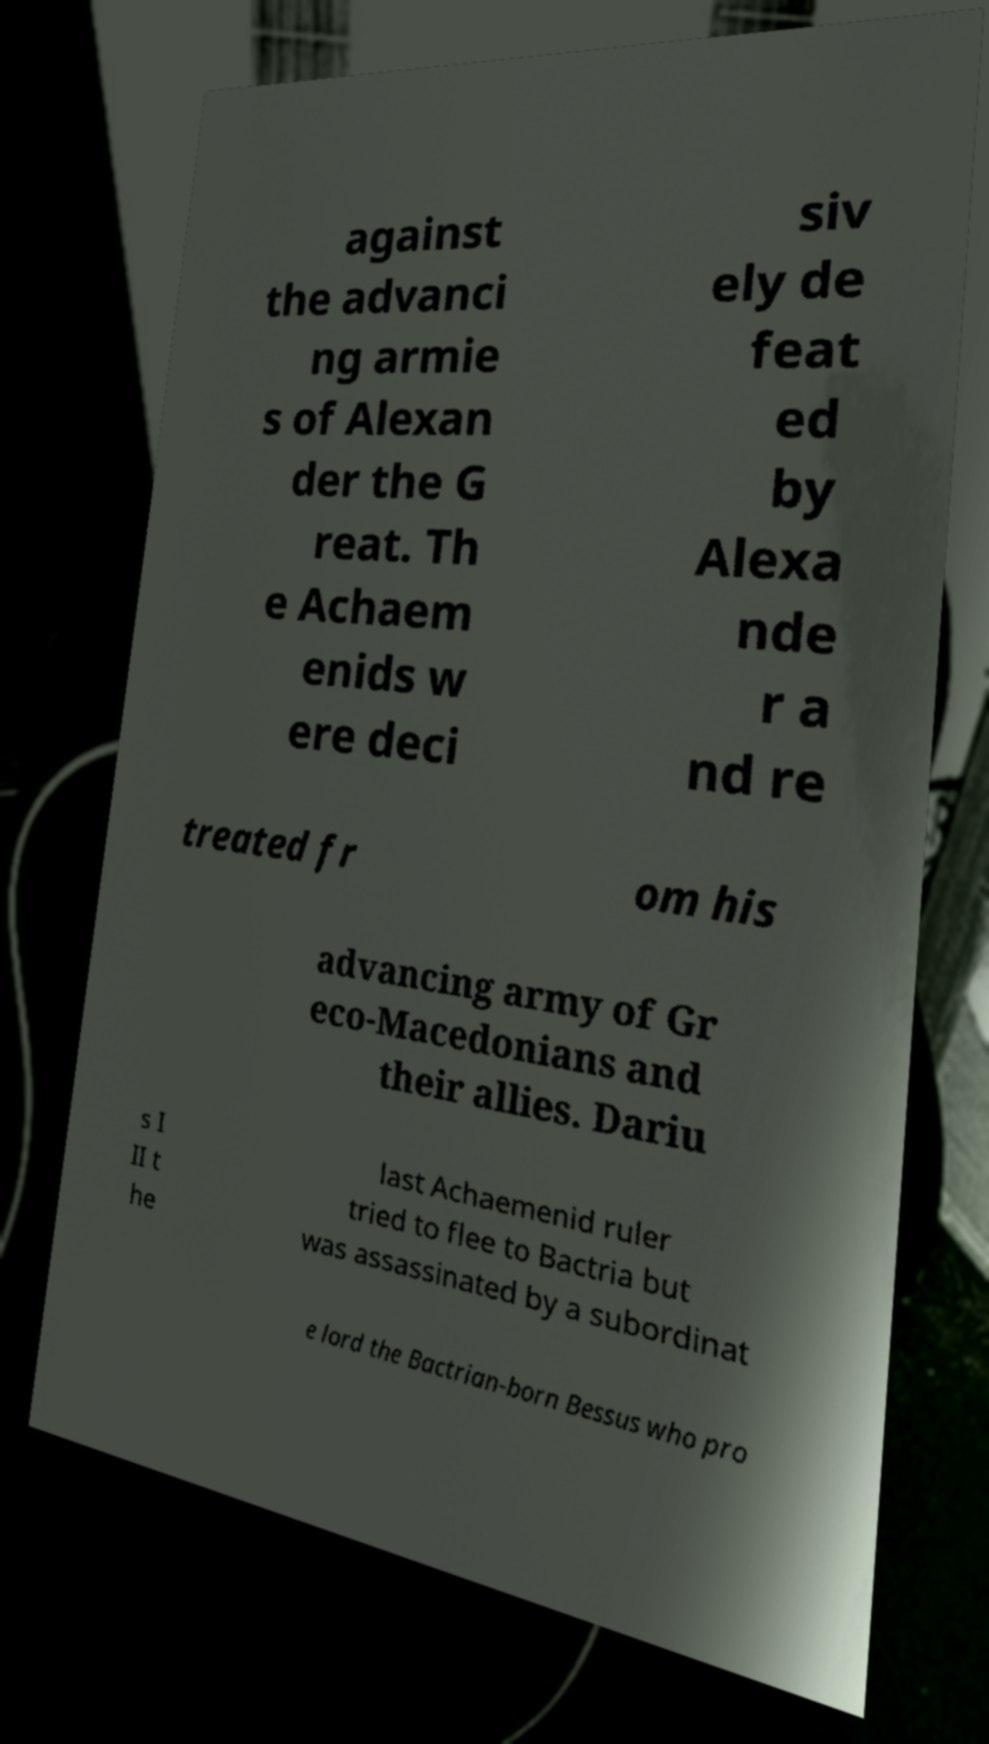What messages or text are displayed in this image? I need them in a readable, typed format. against the advanci ng armie s of Alexan der the G reat. Th e Achaem enids w ere deci siv ely de feat ed by Alexa nde r a nd re treated fr om his advancing army of Gr eco-Macedonians and their allies. Dariu s I II t he last Achaemenid ruler tried to flee to Bactria but was assassinated by a subordinat e lord the Bactrian-born Bessus who pro 